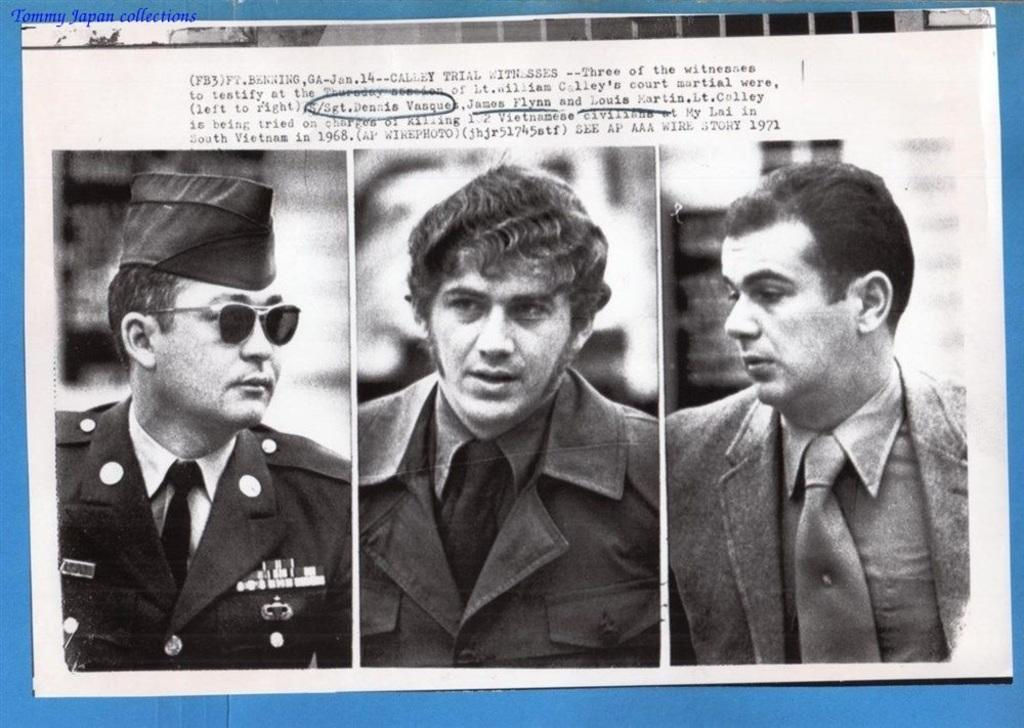What is present on the poster in the image? The poster contains an image and text. Can you describe the image on the poster? Unfortunately, the specific image on the poster cannot be described with the given facts. What is the color of the background in the image? The background of the image is blue. How many turkeys can be seen in the image? There are no turkeys present in the image. What type of currency is depicted on the poster? The given facts do not mention any currency or cent on the poster. 